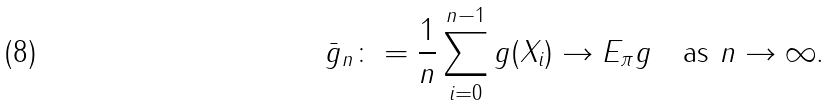<formula> <loc_0><loc_0><loc_500><loc_500>\bar { g } _ { n } \colon = \frac { 1 } { n } \sum _ { i = 0 } ^ { n - 1 } g ( X _ { i } ) \rightarrow E _ { \pi } g \quad \text {as $n \rightarrow \infty$.}</formula> 